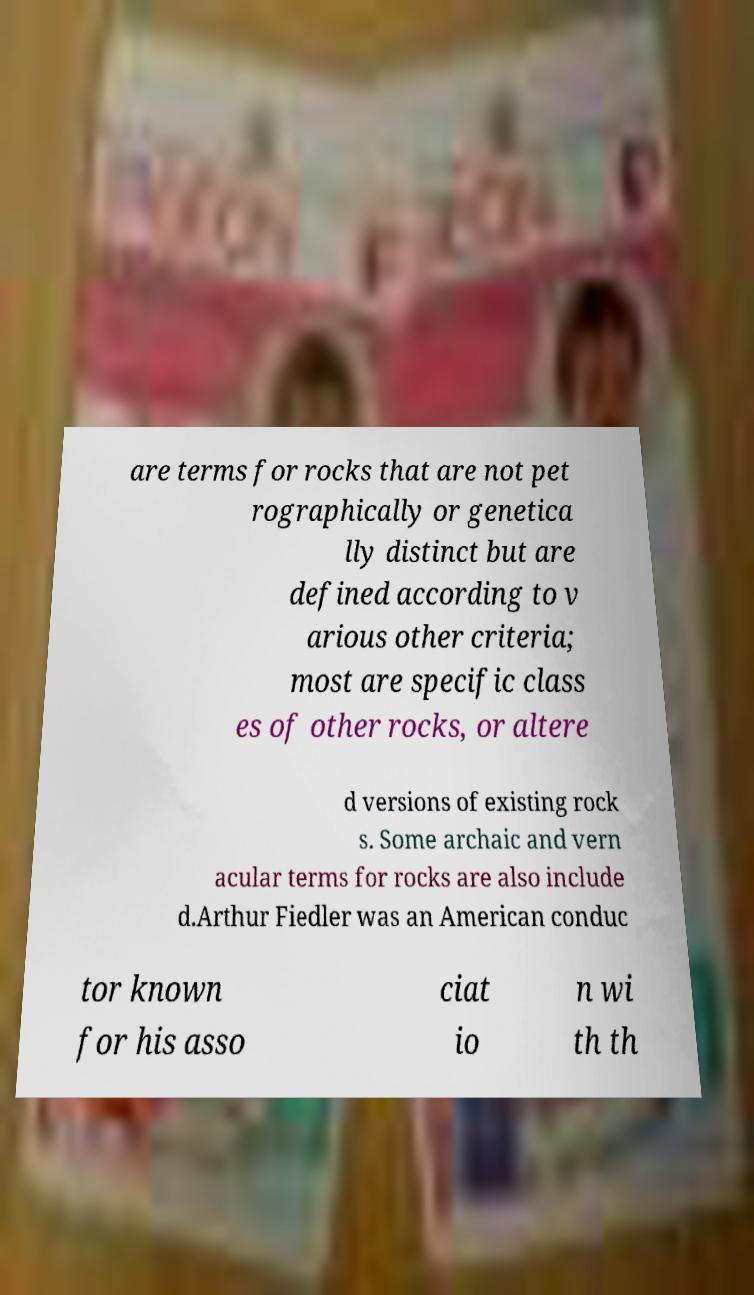Could you assist in decoding the text presented in this image and type it out clearly? are terms for rocks that are not pet rographically or genetica lly distinct but are defined according to v arious other criteria; most are specific class es of other rocks, or altere d versions of existing rock s. Some archaic and vern acular terms for rocks are also include d.Arthur Fiedler was an American conduc tor known for his asso ciat io n wi th th 